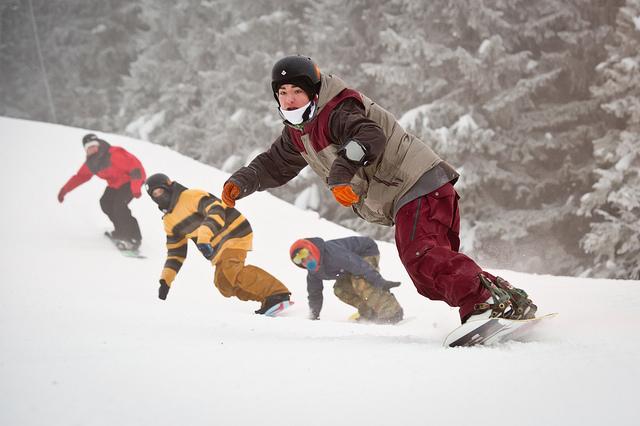Are the people standing straight up?
Quick response, please. No. Are they skiing?
Concise answer only. No. Is the person skiing asian?
Concise answer only. Yes. 